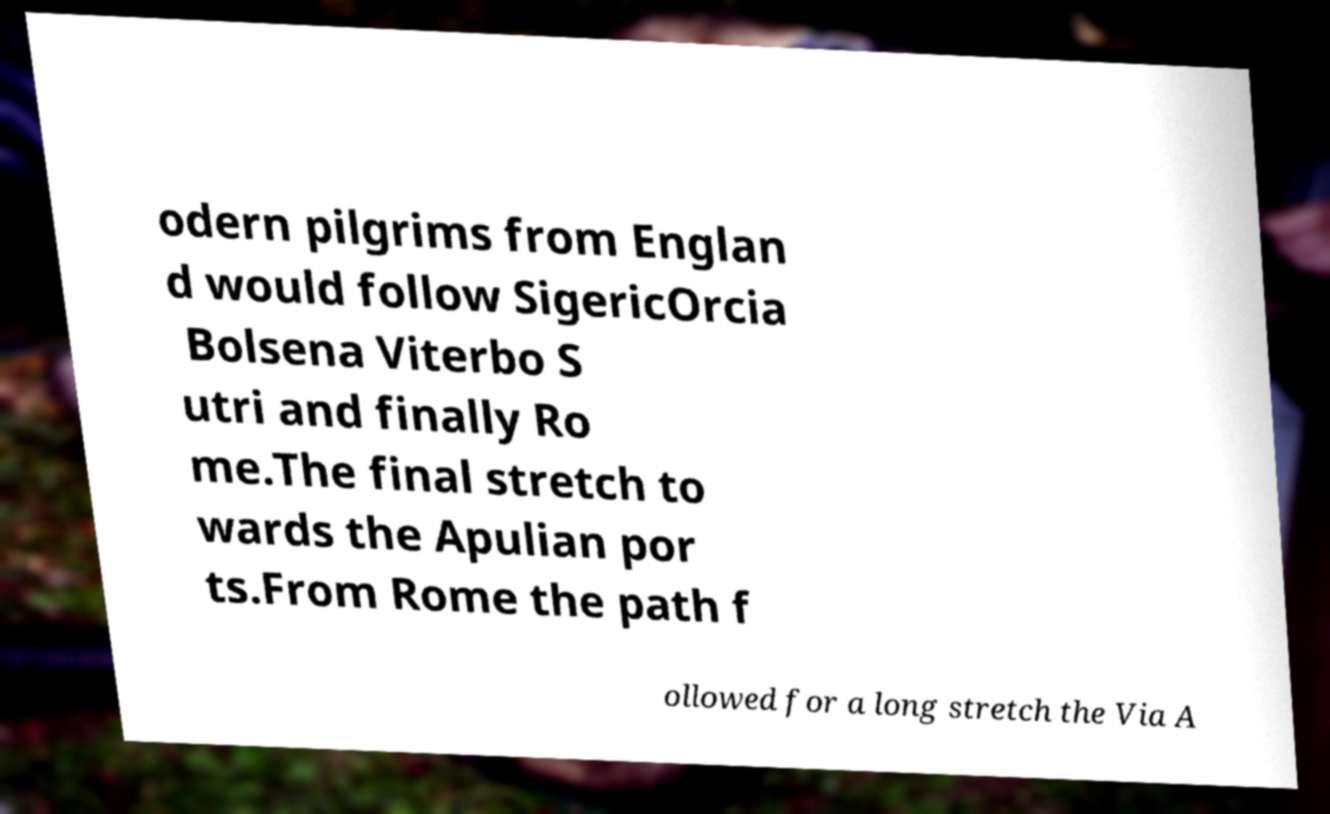Please read and relay the text visible in this image. What does it say? odern pilgrims from Englan d would follow SigericOrcia Bolsena Viterbo S utri and finally Ro me.The final stretch to wards the Apulian por ts.From Rome the path f ollowed for a long stretch the Via A 